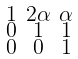Convert formula to latex. <formula><loc_0><loc_0><loc_500><loc_500>\begin{smallmatrix} 1 & 2 \alpha & \alpha \\ 0 & 1 & 1 \\ 0 & 0 & 1 \end{smallmatrix}</formula> 